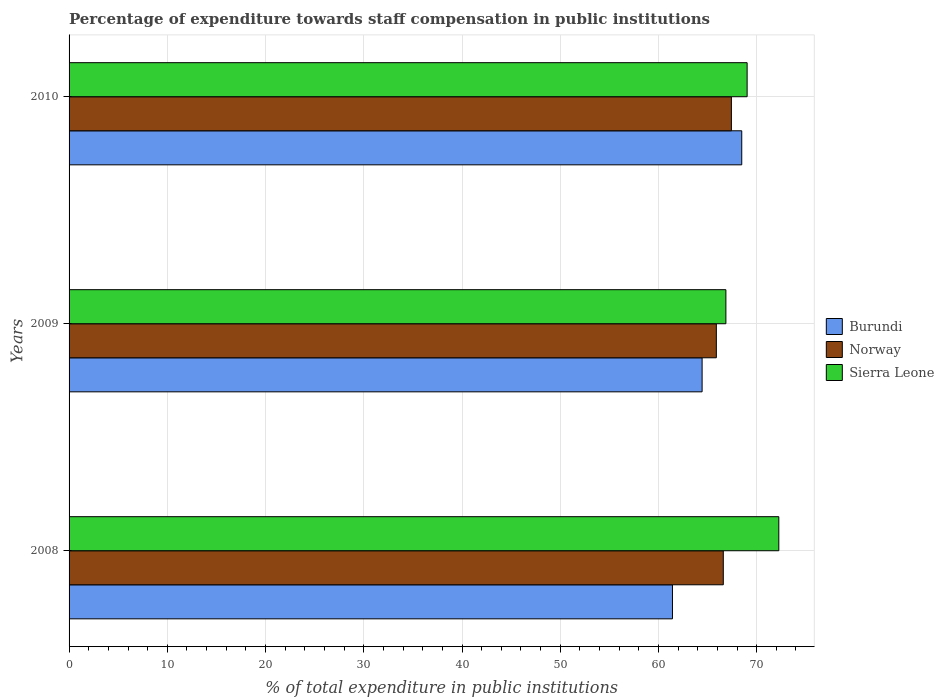How many groups of bars are there?
Offer a very short reply. 3. Are the number of bars on each tick of the Y-axis equal?
Your answer should be compact. Yes. What is the percentage of expenditure towards staff compensation in Sierra Leone in 2009?
Make the answer very short. 66.86. Across all years, what is the maximum percentage of expenditure towards staff compensation in Sierra Leone?
Provide a short and direct response. 72.25. Across all years, what is the minimum percentage of expenditure towards staff compensation in Norway?
Ensure brevity in your answer.  65.89. In which year was the percentage of expenditure towards staff compensation in Norway minimum?
Offer a terse response. 2009. What is the total percentage of expenditure towards staff compensation in Sierra Leone in the graph?
Your response must be concise. 208.14. What is the difference between the percentage of expenditure towards staff compensation in Norway in 2008 and that in 2009?
Your response must be concise. 0.71. What is the difference between the percentage of expenditure towards staff compensation in Norway in 2010 and the percentage of expenditure towards staff compensation in Sierra Leone in 2008?
Offer a very short reply. -4.83. What is the average percentage of expenditure towards staff compensation in Burundi per year?
Your response must be concise. 64.78. In the year 2008, what is the difference between the percentage of expenditure towards staff compensation in Sierra Leone and percentage of expenditure towards staff compensation in Norway?
Provide a succinct answer. 5.65. What is the ratio of the percentage of expenditure towards staff compensation in Norway in 2009 to that in 2010?
Give a very brief answer. 0.98. What is the difference between the highest and the second highest percentage of expenditure towards staff compensation in Burundi?
Offer a terse response. 4.04. What is the difference between the highest and the lowest percentage of expenditure towards staff compensation in Sierra Leone?
Provide a succinct answer. 5.39. In how many years, is the percentage of expenditure towards staff compensation in Norway greater than the average percentage of expenditure towards staff compensation in Norway taken over all years?
Ensure brevity in your answer.  1. Is the sum of the percentage of expenditure towards staff compensation in Norway in 2008 and 2009 greater than the maximum percentage of expenditure towards staff compensation in Burundi across all years?
Keep it short and to the point. Yes. What does the 3rd bar from the top in 2009 represents?
Your answer should be compact. Burundi. What does the 2nd bar from the bottom in 2009 represents?
Your answer should be very brief. Norway. Is it the case that in every year, the sum of the percentage of expenditure towards staff compensation in Norway and percentage of expenditure towards staff compensation in Burundi is greater than the percentage of expenditure towards staff compensation in Sierra Leone?
Provide a short and direct response. Yes. Are all the bars in the graph horizontal?
Keep it short and to the point. Yes. What is the difference between two consecutive major ticks on the X-axis?
Keep it short and to the point. 10. Are the values on the major ticks of X-axis written in scientific E-notation?
Your answer should be very brief. No. Does the graph contain grids?
Your answer should be very brief. Yes. Where does the legend appear in the graph?
Provide a short and direct response. Center right. What is the title of the graph?
Offer a very short reply. Percentage of expenditure towards staff compensation in public institutions. Does "Korea (Republic)" appear as one of the legend labels in the graph?
Your answer should be very brief. No. What is the label or title of the X-axis?
Give a very brief answer. % of total expenditure in public institutions. What is the label or title of the Y-axis?
Make the answer very short. Years. What is the % of total expenditure in public institutions of Burundi in 2008?
Provide a succinct answer. 61.43. What is the % of total expenditure in public institutions in Norway in 2008?
Make the answer very short. 66.6. What is the % of total expenditure in public institutions of Sierra Leone in 2008?
Offer a very short reply. 72.25. What is the % of total expenditure in public institutions in Burundi in 2009?
Give a very brief answer. 64.44. What is the % of total expenditure in public institutions in Norway in 2009?
Give a very brief answer. 65.89. What is the % of total expenditure in public institutions of Sierra Leone in 2009?
Offer a terse response. 66.86. What is the % of total expenditure in public institutions in Burundi in 2010?
Provide a succinct answer. 68.48. What is the % of total expenditure in public institutions in Norway in 2010?
Make the answer very short. 67.42. What is the % of total expenditure in public institutions of Sierra Leone in 2010?
Make the answer very short. 69.03. Across all years, what is the maximum % of total expenditure in public institutions of Burundi?
Your answer should be very brief. 68.48. Across all years, what is the maximum % of total expenditure in public institutions in Norway?
Give a very brief answer. 67.42. Across all years, what is the maximum % of total expenditure in public institutions in Sierra Leone?
Offer a terse response. 72.25. Across all years, what is the minimum % of total expenditure in public institutions in Burundi?
Ensure brevity in your answer.  61.43. Across all years, what is the minimum % of total expenditure in public institutions of Norway?
Provide a succinct answer. 65.89. Across all years, what is the minimum % of total expenditure in public institutions of Sierra Leone?
Offer a very short reply. 66.86. What is the total % of total expenditure in public institutions of Burundi in the graph?
Your answer should be very brief. 194.35. What is the total % of total expenditure in public institutions of Norway in the graph?
Offer a terse response. 199.92. What is the total % of total expenditure in public institutions in Sierra Leone in the graph?
Make the answer very short. 208.14. What is the difference between the % of total expenditure in public institutions in Burundi in 2008 and that in 2009?
Your answer should be compact. -3.02. What is the difference between the % of total expenditure in public institutions in Norway in 2008 and that in 2009?
Provide a short and direct response. 0.71. What is the difference between the % of total expenditure in public institutions in Sierra Leone in 2008 and that in 2009?
Provide a succinct answer. 5.39. What is the difference between the % of total expenditure in public institutions of Burundi in 2008 and that in 2010?
Your response must be concise. -7.05. What is the difference between the % of total expenditure in public institutions in Norway in 2008 and that in 2010?
Give a very brief answer. -0.82. What is the difference between the % of total expenditure in public institutions in Sierra Leone in 2008 and that in 2010?
Provide a succinct answer. 3.23. What is the difference between the % of total expenditure in public institutions of Burundi in 2009 and that in 2010?
Your response must be concise. -4.04. What is the difference between the % of total expenditure in public institutions in Norway in 2009 and that in 2010?
Keep it short and to the point. -1.53. What is the difference between the % of total expenditure in public institutions of Sierra Leone in 2009 and that in 2010?
Your response must be concise. -2.16. What is the difference between the % of total expenditure in public institutions in Burundi in 2008 and the % of total expenditure in public institutions in Norway in 2009?
Your answer should be very brief. -4.47. What is the difference between the % of total expenditure in public institutions in Burundi in 2008 and the % of total expenditure in public institutions in Sierra Leone in 2009?
Your answer should be compact. -5.44. What is the difference between the % of total expenditure in public institutions of Norway in 2008 and the % of total expenditure in public institutions of Sierra Leone in 2009?
Offer a very short reply. -0.26. What is the difference between the % of total expenditure in public institutions in Burundi in 2008 and the % of total expenditure in public institutions in Norway in 2010?
Your response must be concise. -6. What is the difference between the % of total expenditure in public institutions of Burundi in 2008 and the % of total expenditure in public institutions of Sierra Leone in 2010?
Provide a succinct answer. -7.6. What is the difference between the % of total expenditure in public institutions in Norway in 2008 and the % of total expenditure in public institutions in Sierra Leone in 2010?
Offer a very short reply. -2.43. What is the difference between the % of total expenditure in public institutions of Burundi in 2009 and the % of total expenditure in public institutions of Norway in 2010?
Your answer should be compact. -2.98. What is the difference between the % of total expenditure in public institutions of Burundi in 2009 and the % of total expenditure in public institutions of Sierra Leone in 2010?
Offer a very short reply. -4.58. What is the difference between the % of total expenditure in public institutions of Norway in 2009 and the % of total expenditure in public institutions of Sierra Leone in 2010?
Your answer should be compact. -3.13. What is the average % of total expenditure in public institutions in Burundi per year?
Give a very brief answer. 64.78. What is the average % of total expenditure in public institutions in Norway per year?
Keep it short and to the point. 66.64. What is the average % of total expenditure in public institutions in Sierra Leone per year?
Give a very brief answer. 69.38. In the year 2008, what is the difference between the % of total expenditure in public institutions of Burundi and % of total expenditure in public institutions of Norway?
Provide a succinct answer. -5.18. In the year 2008, what is the difference between the % of total expenditure in public institutions of Burundi and % of total expenditure in public institutions of Sierra Leone?
Provide a short and direct response. -10.83. In the year 2008, what is the difference between the % of total expenditure in public institutions in Norway and % of total expenditure in public institutions in Sierra Leone?
Provide a short and direct response. -5.65. In the year 2009, what is the difference between the % of total expenditure in public institutions of Burundi and % of total expenditure in public institutions of Norway?
Ensure brevity in your answer.  -1.45. In the year 2009, what is the difference between the % of total expenditure in public institutions in Burundi and % of total expenditure in public institutions in Sierra Leone?
Offer a very short reply. -2.42. In the year 2009, what is the difference between the % of total expenditure in public institutions of Norway and % of total expenditure in public institutions of Sierra Leone?
Provide a short and direct response. -0.97. In the year 2010, what is the difference between the % of total expenditure in public institutions of Burundi and % of total expenditure in public institutions of Norway?
Your response must be concise. 1.05. In the year 2010, what is the difference between the % of total expenditure in public institutions of Burundi and % of total expenditure in public institutions of Sierra Leone?
Make the answer very short. -0.55. In the year 2010, what is the difference between the % of total expenditure in public institutions in Norway and % of total expenditure in public institutions in Sierra Leone?
Provide a succinct answer. -1.6. What is the ratio of the % of total expenditure in public institutions in Burundi in 2008 to that in 2009?
Your answer should be compact. 0.95. What is the ratio of the % of total expenditure in public institutions of Norway in 2008 to that in 2009?
Your response must be concise. 1.01. What is the ratio of the % of total expenditure in public institutions of Sierra Leone in 2008 to that in 2009?
Your answer should be very brief. 1.08. What is the ratio of the % of total expenditure in public institutions in Burundi in 2008 to that in 2010?
Give a very brief answer. 0.9. What is the ratio of the % of total expenditure in public institutions in Norway in 2008 to that in 2010?
Give a very brief answer. 0.99. What is the ratio of the % of total expenditure in public institutions in Sierra Leone in 2008 to that in 2010?
Ensure brevity in your answer.  1.05. What is the ratio of the % of total expenditure in public institutions of Burundi in 2009 to that in 2010?
Ensure brevity in your answer.  0.94. What is the ratio of the % of total expenditure in public institutions of Norway in 2009 to that in 2010?
Offer a very short reply. 0.98. What is the ratio of the % of total expenditure in public institutions of Sierra Leone in 2009 to that in 2010?
Provide a succinct answer. 0.97. What is the difference between the highest and the second highest % of total expenditure in public institutions in Burundi?
Keep it short and to the point. 4.04. What is the difference between the highest and the second highest % of total expenditure in public institutions of Norway?
Offer a terse response. 0.82. What is the difference between the highest and the second highest % of total expenditure in public institutions of Sierra Leone?
Provide a succinct answer. 3.23. What is the difference between the highest and the lowest % of total expenditure in public institutions of Burundi?
Your response must be concise. 7.05. What is the difference between the highest and the lowest % of total expenditure in public institutions in Norway?
Keep it short and to the point. 1.53. What is the difference between the highest and the lowest % of total expenditure in public institutions of Sierra Leone?
Ensure brevity in your answer.  5.39. 